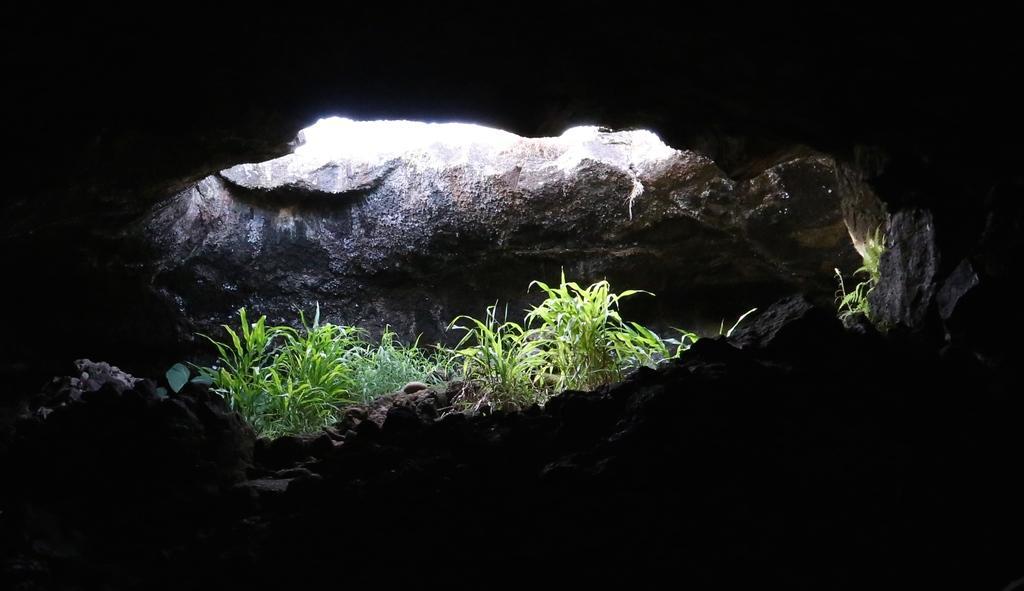Could you give a brief overview of what you see in this image? This picture is inside view of a cave. We can see some rocks and plants are present. 